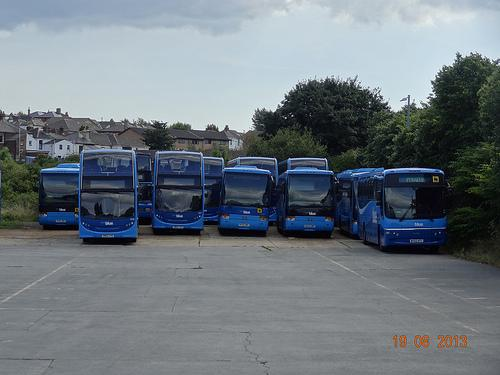Describe the setting in which the buses are located in this image. The buses are parked in an outdoor location with trees, buildings, and a blue sky in the background. If this image were meant to convey a sentiment or emotion, what would it be? The image may convey a sense of organization or orderliness due to the neat row of parked blue buses. Using the information about the objects in the image, what reasoning or deductions can you make about the scene? From the available information, it can be inferred that the scene depicts a well-organized setting of parked blue buses, likely in a public transportation or vehicle storage context. How would you describe the quality of the image based on the available information? The quality of the image appears to be detailed and accurate, with specific information about the position and size of objects. Analyze the objects in the image and tell me the predominant object's colors. The image predominantly contains blue buses, green trees, and a blue and gray sky. What are the primary colors in this image? The primary colors in this image are blue, gray, and green. Give a one-sentence description of the scene depicted in this image. Blue buses are parked in a row with trees, buildings, and a blue sky filled with clouds in the background. Count the number of buses in the image and describe their color. There are multiple blue buses in the image. Identify the natural elements in the image and describe their general appearance. In the image, there are green trees and a blue sky with blue and gray clouds. Based on the image information, is it possible to describe any object interactions or relationships? There are no specific object interactions described in the image, but the buses are parked in proximity to each other. Are there any yellow umbrellas near the buses protecting people from the rain? No, it's not mentioned in the image. 